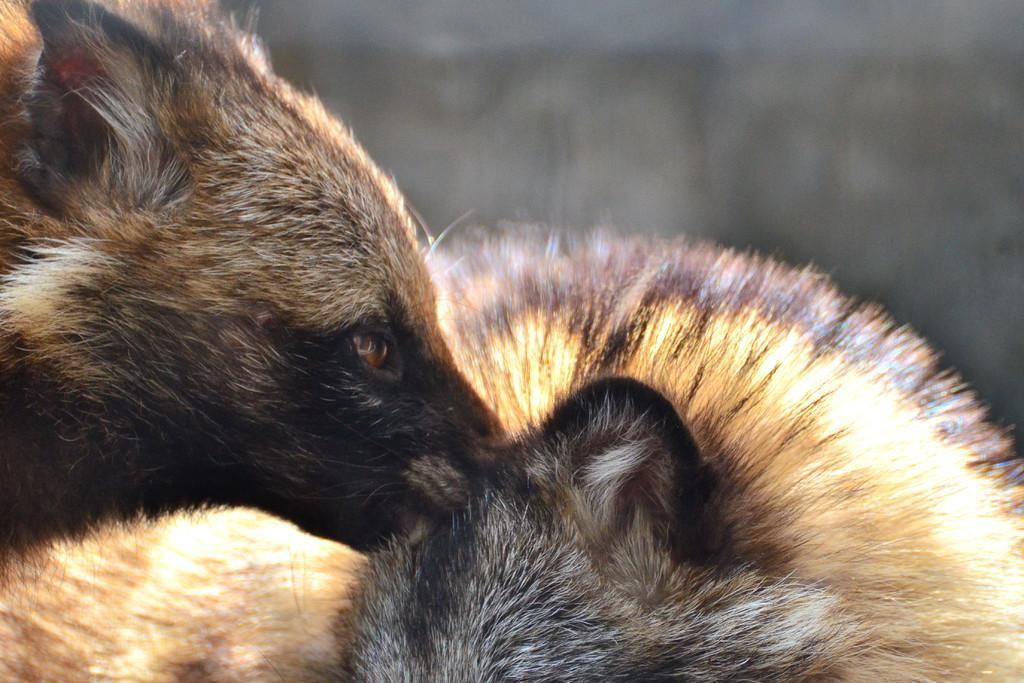Describe this image in one or two sentences. In the picture I can see animals. The background of the image is blurred. 